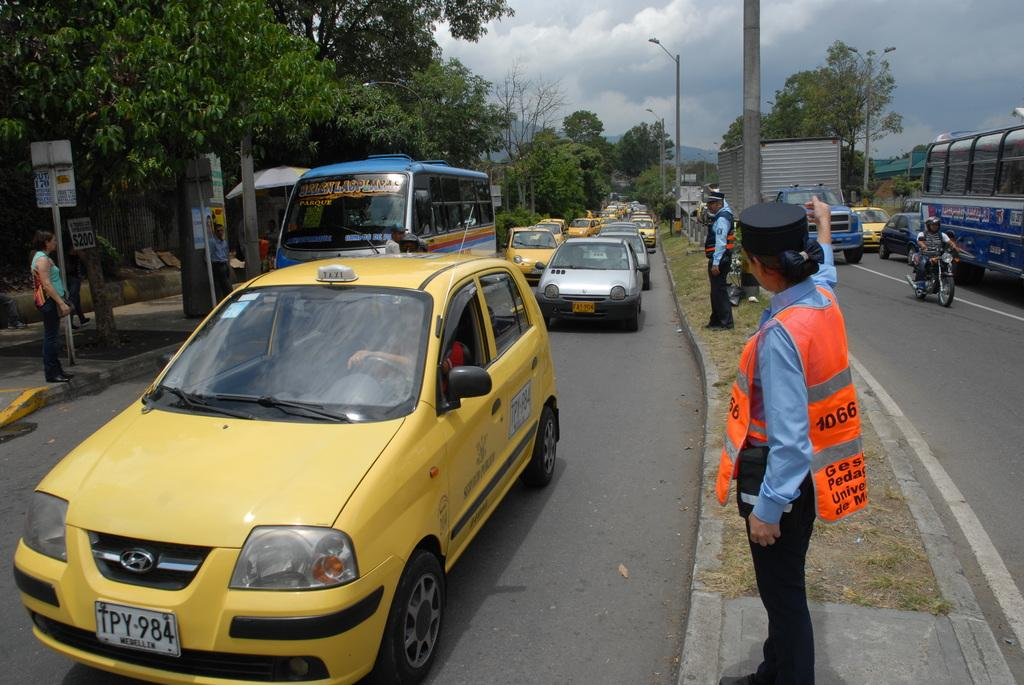Provide a one-sentence caption for the provided image. A police officer directs a yellow taxi with the license plate TPY-984. 